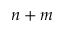<formula> <loc_0><loc_0><loc_500><loc_500>n + m</formula> 